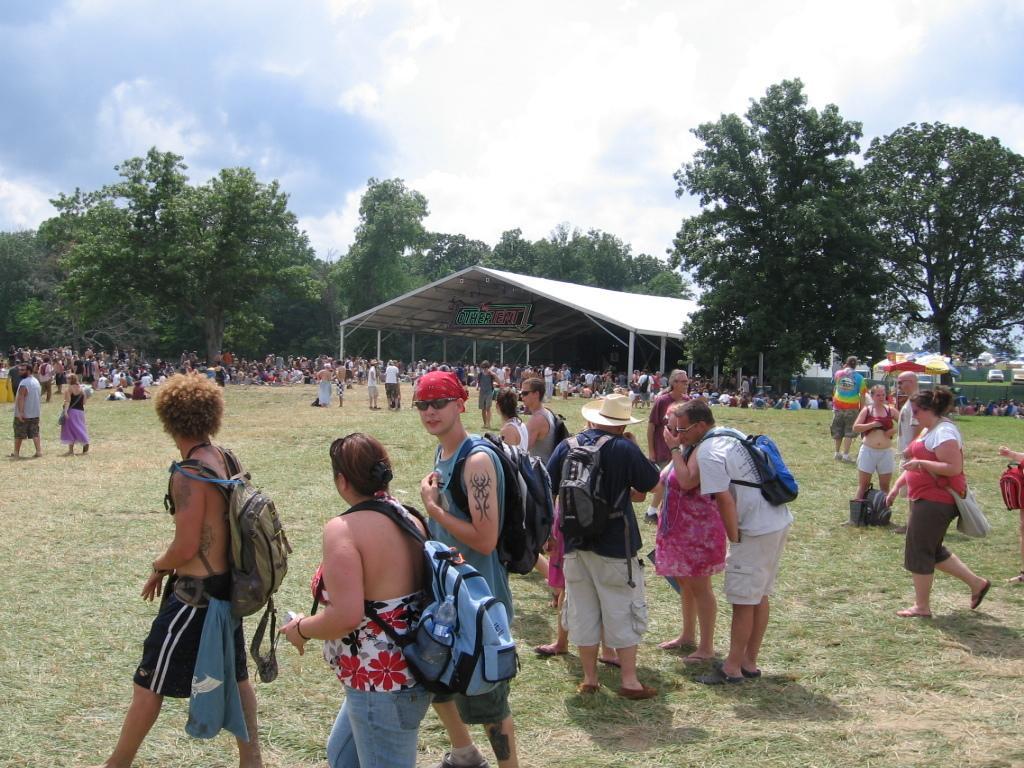Could you give a brief overview of what you see in this image? In this picture I can see group of people standing, there is a shed, there are trees, and in the background there is the sky. 